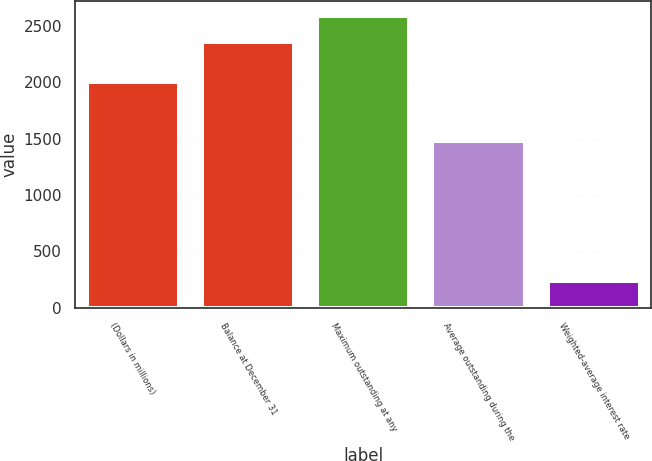Convert chart. <chart><loc_0><loc_0><loc_500><loc_500><bar_chart><fcel>(Dollars in millions)<fcel>Balance at December 31<fcel>Maximum outstanding at any<fcel>Average outstanding during the<fcel>Weighted-average interest rate<nl><fcel>2007<fcel>2355<fcel>2590.08<fcel>1478<fcel>239.31<nl></chart> 